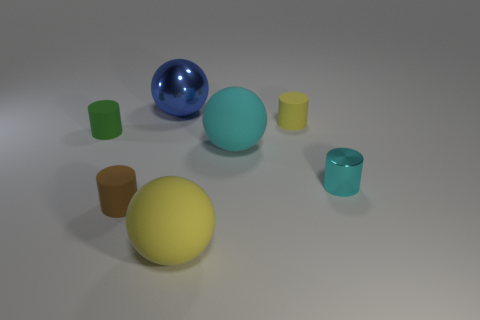Subtract all tiny green matte cylinders. How many cylinders are left? 3 Add 1 large yellow things. How many objects exist? 8 Subtract all yellow balls. How many balls are left? 2 Add 2 metal cylinders. How many metal cylinders are left? 3 Add 1 big blue metallic spheres. How many big blue metallic spheres exist? 2 Subtract 0 red cylinders. How many objects are left? 7 Subtract all balls. How many objects are left? 4 Subtract 3 cylinders. How many cylinders are left? 1 Subtract all red cylinders. Subtract all purple cubes. How many cylinders are left? 4 Subtract all cyan balls. Subtract all large spheres. How many objects are left? 3 